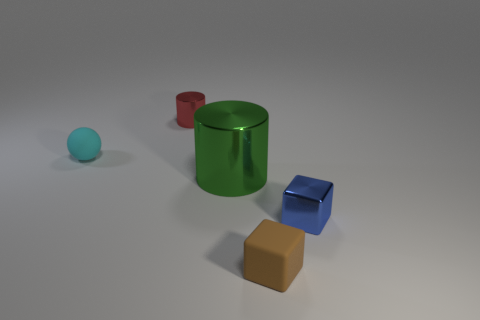Are there any other things that have the same size as the green metal cylinder?
Offer a terse response. No. Does the small blue object have the same shape as the tiny matte thing in front of the big metallic thing?
Keep it short and to the point. Yes. What number of big green metallic cylinders are on the right side of the cyan object in front of the small metallic object on the left side of the green cylinder?
Your answer should be compact. 1. What color is the other metal thing that is the same shape as the red object?
Your response must be concise. Green. Is there anything else that has the same shape as the cyan rubber thing?
Provide a succinct answer. No. How many cylinders are green objects or red things?
Your response must be concise. 2. There is a blue thing; what shape is it?
Make the answer very short. Cube. Are there any small blue shiny things right of the big green object?
Provide a succinct answer. Yes. Do the tiny red cylinder and the block that is right of the brown rubber thing have the same material?
Provide a succinct answer. Yes. There is a metal object that is behind the tiny cyan rubber ball; is it the same shape as the large green shiny object?
Keep it short and to the point. Yes. 